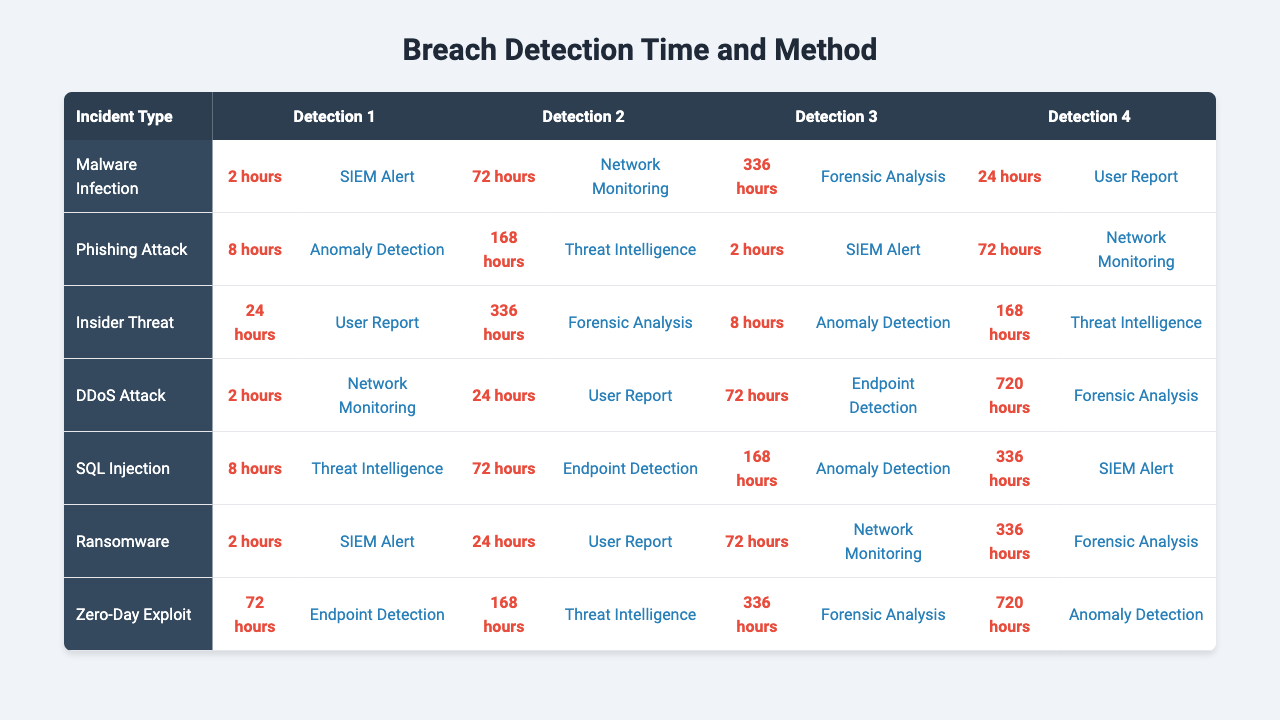What is the detection method for a Malware Infection incident? According to the table, the detection method for a Malware Infection incident is "SIEM Alert" with a detection time of 2 hours.
Answer: SIEM Alert How long does it take to detect a Phishing Attack? The table shows that the detection time for a Phishing Attack is 8 hours based on the detection method "Anomaly Detection".
Answer: 8 hours Is "User Report" a detection method for SQL Injection? The table indicates that "User Report" is not a detection method listed for SQL Injection; the detection methods associated with it are "Threat Intelligence" and "Anomaly Detection".
Answer: No What is the detection time for the longest detected incident? The longest detection time is 720 hours for a Zero-Day Exploit based on "Forensic Analysis".
Answer: 720 hours Which detection method has the shortest average detection time? To find the shortest average, we need to calculate the average detection time for all detection methods and compare them. Summarizing from the table, "SIEM Alert" has a time of 2, "Anomaly Detection" has 8, "User Report" has 24, "Threat Intelligence" has 72, etc. The method "SIEM Alert" shows the lowest average detection time overall with 2 hours.
Answer: SIEM Alert How many hours does it take, on average, to detect incidents using "Forensic Analysis"? Analyzing the table, "Forensic Analysis" appears with the detection times of 336 hours (for Malware Infection), 336 hours (for Phishing Attack), 720 hours (for Zero-Day Exploit), and 72 hours (for DDoS Attack). The average is calculated as (336 + 336 + 72 + 720) / 4 = 366.
Answer: 366 hours What is the detection method with the highest detection time for an Insider Threat? The detection time for an Insider Threat when applying "Forensic Analysis" is 336 hours, which is the highest among the listed detection methods for this incident type.
Answer: Forensic Analysis Are there any incident types with the same detection times? Yes, the incident types of Malware Infection and Phishing Attack both have "SIEM Alert" as the detection method, and they share the same detection time of 2 hours.
Answer: Yes What is the total detection time for all methods used in detecting DDoS Attacks? The detection times for DDoS Attacks from the table are 72 hours (for Endpoint Detection), 168 hours (for Threat Intelligence), and 336 hours (for Forensic Analysis). Summing these gives us a total of 72 + 168 + 336 = 576 hours.
Answer: 576 hours Which incident type has the longest detection time associated with "Network Monitoring"? The incident type associated with "Network Monitoring" is Malware Infection with a detection time of 72 hours, identified among other incident types in the table.
Answer: Malware Infection 